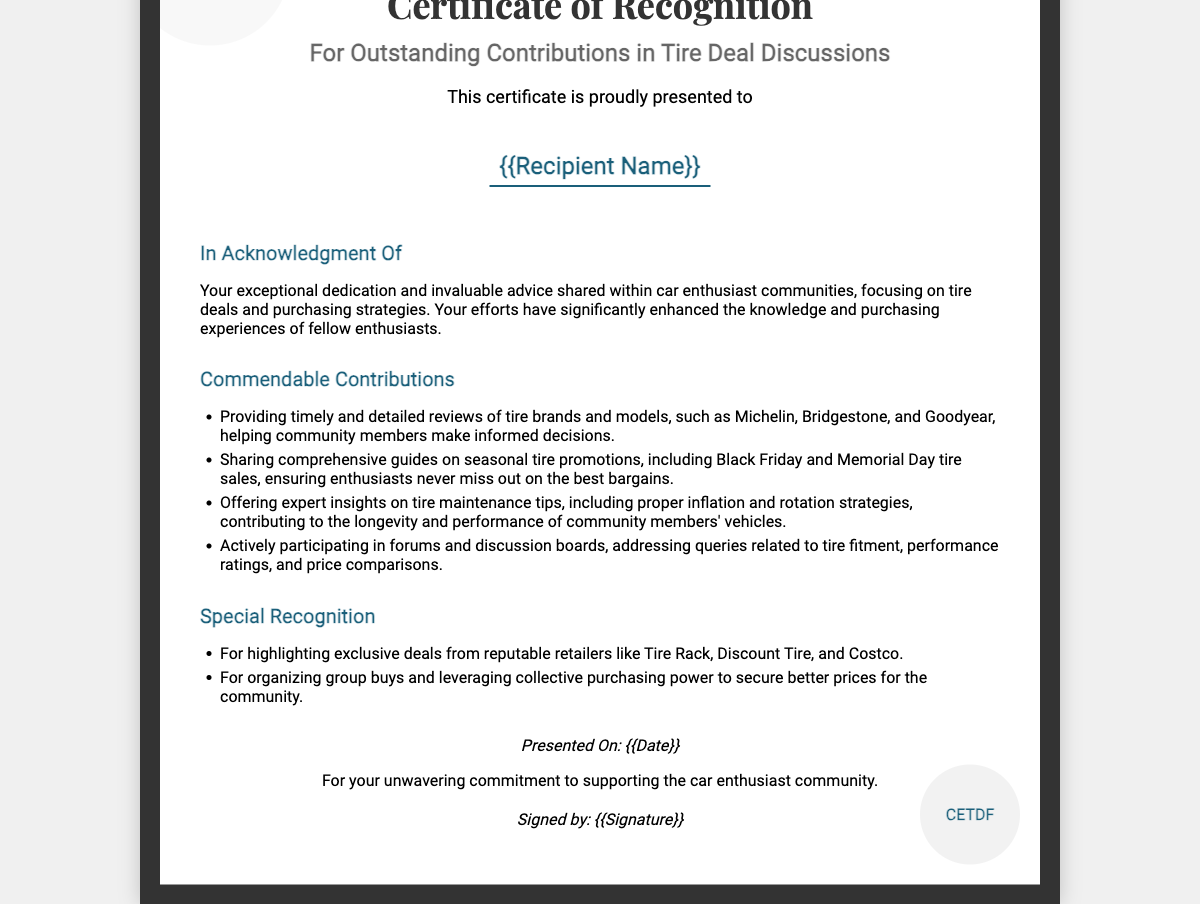What is the title of the certificate? The title of the certificate is prominently displayed at the top and indicates its purpose.
Answer: Certificate of Recognition Who is the recipient of the certificate? The recipient's name is mentioned in a specific section designated for that purpose.
Answer: {{Recipient Name}} What is acknowledged in the certificate? The certificate states the purpose of recognition, focusing on community contributions.
Answer: Exceptional dedication and invaluable advice What is one brand mentioned for tire reviews? The document lists specific tire brands as examples for reviews provided by the recipient.
Answer: Michelin What is a special recognition provided in the certificate? This section includes specific actions or contributions that received special acknowledgment.
Answer: Highlighting exclusive deals When was the certificate presented? The date of presentation is specifically mentioned at the bottom of the document.
Answer: {{Date}} Who signed the certificate? The signature section provides the name or title of the person acknowledging the recipient's contributions.
Answer: {{Signature}} How many contributions are listed under commendable contributions? The number is derived from the bullet points provided in that section of the document.
Answer: Four 